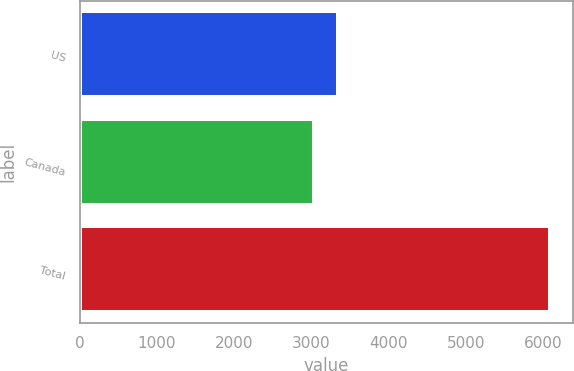Convert chart. <chart><loc_0><loc_0><loc_500><loc_500><bar_chart><fcel>US<fcel>Canada<fcel>Total<nl><fcel>3337.6<fcel>3033<fcel>6079<nl></chart> 